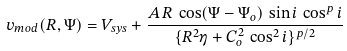Convert formula to latex. <formula><loc_0><loc_0><loc_500><loc_500>v _ { m o d } ( R , \Psi ) = V _ { s y s } + \frac { A \, R \, \cos ( \Psi - \Psi _ { o } ) \, \sin i \, \cos ^ { p } i } { \{ R ^ { 2 } \eta + C _ { o } ^ { 2 } \, \cos ^ { 2 } i \} ^ { p / 2 } }</formula> 